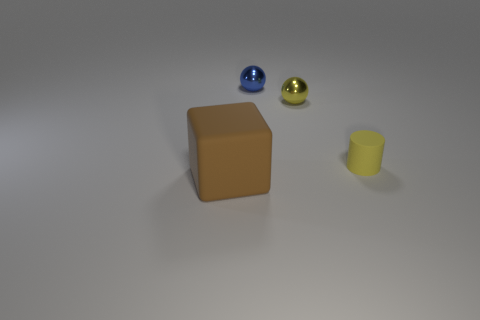Are there any other things that have the same shape as the large thing?
Provide a short and direct response. No. Are there any other things that have the same size as the brown matte thing?
Provide a short and direct response. No. What material is the thing that is the same color as the tiny matte cylinder?
Make the answer very short. Metal. Are the small yellow object that is behind the small matte cylinder and the tiny blue ball made of the same material?
Your response must be concise. Yes. How many objects are either tiny yellow things or objects that are behind the large brown thing?
Your answer should be very brief. 3. There is a shiny ball to the right of the small metal ball behind the yellow ball; what number of brown rubber objects are in front of it?
Offer a very short reply. 1. There is a shiny thing in front of the blue shiny object; is it the same shape as the tiny blue shiny thing?
Keep it short and to the point. Yes. There is a tiny yellow thing that is behind the small matte cylinder; are there any blue balls on the left side of it?
Your answer should be compact. Yes. What number of small blue shiny things are there?
Ensure brevity in your answer.  1. What is the color of the thing that is behind the big rubber object and in front of the yellow sphere?
Provide a succinct answer. Yellow. 